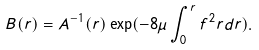<formula> <loc_0><loc_0><loc_500><loc_500>B ( r ) = A ^ { - 1 } ( r ) \exp ( - 8 \mu \int _ { 0 } ^ { r } f ^ { 2 } r { d r } ) .</formula> 